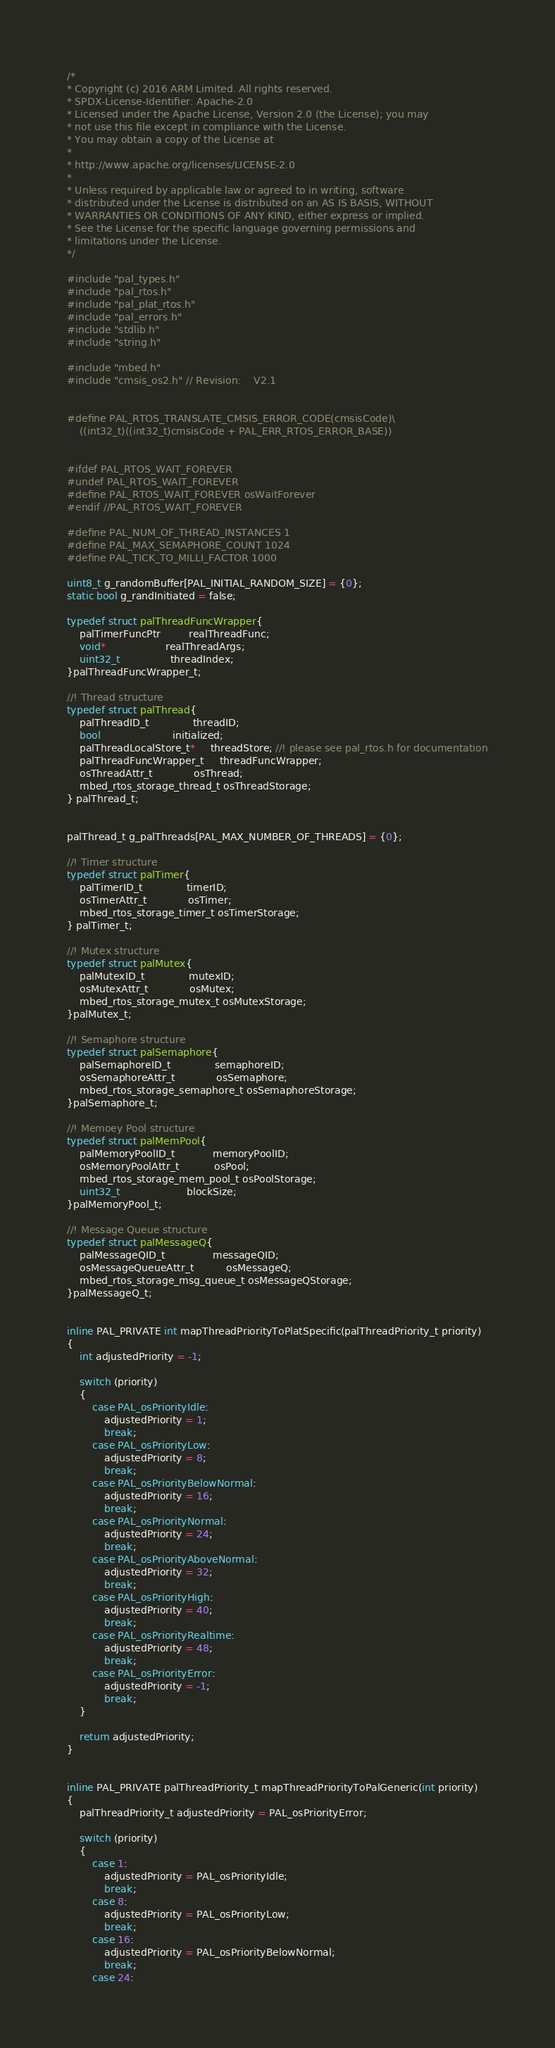<code> <loc_0><loc_0><loc_500><loc_500><_C++_>/*
* Copyright (c) 2016 ARM Limited. All rights reserved.
* SPDX-License-Identifier: Apache-2.0
* Licensed under the Apache License, Version 2.0 (the License); you may
* not use this file except in compliance with the License.
* You may obtain a copy of the License at
*
* http://www.apache.org/licenses/LICENSE-2.0
*
* Unless required by applicable law or agreed to in writing, software
* distributed under the License is distributed on an AS IS BASIS, WITHOUT
* WARRANTIES OR CONDITIONS OF ANY KIND, either express or implied.
* See the License for the specific language governing permissions and
* limitations under the License.
*/

#include "pal_types.h"
#include "pal_rtos.h"
#include "pal_plat_rtos.h"
#include "pal_errors.h"
#include "stdlib.h"
#include "string.h"

#include "mbed.h"
#include "cmsis_os2.h" // Revision:    V2.1


#define PAL_RTOS_TRANSLATE_CMSIS_ERROR_CODE(cmsisCode)\
    ((int32_t)((int32_t)cmsisCode + PAL_ERR_RTOS_ERROR_BASE))


#ifdef PAL_RTOS_WAIT_FOREVER
#undef PAL_RTOS_WAIT_FOREVER
#define PAL_RTOS_WAIT_FOREVER osWaitForever
#endif //PAL_RTOS_WAIT_FOREVER

#define PAL_NUM_OF_THREAD_INSTANCES 1
#define PAL_MAX_SEMAPHORE_COUNT 1024
#define PAL_TICK_TO_MILLI_FACTOR 1000

uint8_t g_randomBuffer[PAL_INITIAL_RANDOM_SIZE] = {0};
static bool g_randInitiated = false;

typedef struct palThreadFuncWrapper{
    palTimerFuncPtr         realThreadFunc;
    void*                   realThreadArgs;
    uint32_t                threadIndex;
}palThreadFuncWrapper_t;

//! Thread structure
typedef struct palThread{
    palThreadID_t              threadID;
    bool                       initialized;
    palThreadLocalStore_t*     threadStore; //! please see pal_rtos.h for documentation
    palThreadFuncWrapper_t     threadFuncWrapper;
    osThreadAttr_t             osThread;
    mbed_rtos_storage_thread_t osThreadStorage;
} palThread_t;


palThread_t g_palThreads[PAL_MAX_NUMBER_OF_THREADS] = {0};

//! Timer structure
typedef struct palTimer{
    palTimerID_t              timerID;
    osTimerAttr_t             osTimer;
    mbed_rtos_storage_timer_t osTimerStorage;
} palTimer_t;

//! Mutex structure
typedef struct palMutex{
    palMutexID_t              mutexID;
    osMutexAttr_t             osMutex;
    mbed_rtos_storage_mutex_t osMutexStorage;
}palMutex_t;

//! Semaphore structure
typedef struct palSemaphore{
    palSemaphoreID_t              semaphoreID;
    osSemaphoreAttr_t             osSemaphore;
    mbed_rtos_storage_semaphore_t osSemaphoreStorage;
}palSemaphore_t;

//! Memoey Pool structure
typedef struct palMemPool{
    palMemoryPoolID_t            memoryPoolID;
    osMemoryPoolAttr_t           osPool;
    mbed_rtos_storage_mem_pool_t osPoolStorage;
    uint32_t                     blockSize;
}palMemoryPool_t;

//! Message Queue structure
typedef struct palMessageQ{
    palMessageQID_t               messageQID;
    osMessageQueueAttr_t          osMessageQ;
    mbed_rtos_storage_msg_queue_t osMessageQStorage;
}palMessageQ_t;


inline PAL_PRIVATE int mapThreadPriorityToPlatSpecific(palThreadPriority_t priority)
{
    int adjustedPriority = -1;

    switch (priority)
    {
        case PAL_osPriorityIdle:
            adjustedPriority = 1;
            break;
        case PAL_osPriorityLow:
            adjustedPriority = 8;        
            break;
        case PAL_osPriorityBelowNormal:
            adjustedPriority = 16;        
            break;
        case PAL_osPriorityNormal:
            adjustedPriority = 24;        
            break;
        case PAL_osPriorityAboveNormal:
            adjustedPriority = 32;        
            break;
        case PAL_osPriorityHigh:
            adjustedPriority = 40;        
            break;
        case PAL_osPriorityRealtime:
            adjustedPriority = 48;        
            break;
        case PAL_osPriorityError:
            adjustedPriority = -1;        
            break;
    }

    return adjustedPriority;
}


inline PAL_PRIVATE palThreadPriority_t mapThreadPriorityToPalGeneric(int priority)
{
    palThreadPriority_t adjustedPriority = PAL_osPriorityError;

    switch (priority)
    {
        case 1:
            adjustedPriority = PAL_osPriorityIdle;
            break;
        case 8:
            adjustedPriority = PAL_osPriorityLow;        
            break;
        case 16:
            adjustedPriority = PAL_osPriorityBelowNormal;        
            break;
        case 24:</code> 